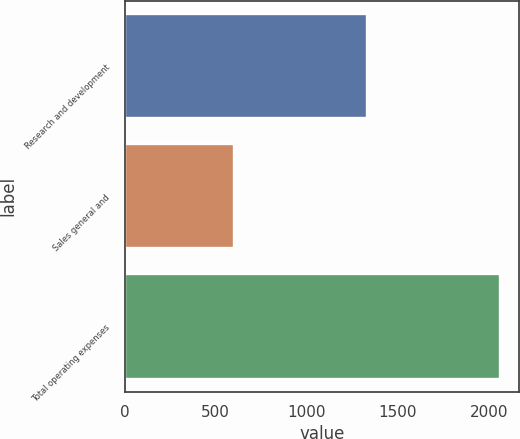<chart> <loc_0><loc_0><loc_500><loc_500><bar_chart><fcel>Research and development<fcel>Sales general and<fcel>Total operating expenses<nl><fcel>1331<fcel>602<fcel>2064<nl></chart> 